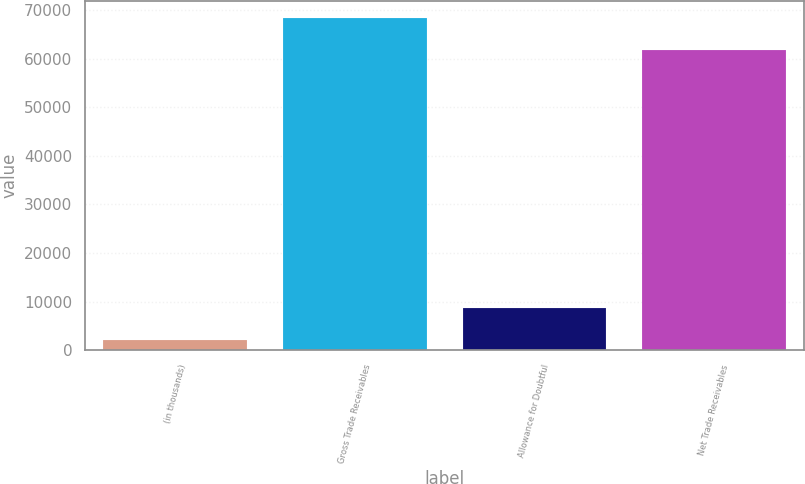<chart> <loc_0><loc_0><loc_500><loc_500><bar_chart><fcel>(in thousands)<fcel>Gross Trade Receivables<fcel>Allowance for Doubtful<fcel>Net Trade Receivables<nl><fcel>2011<fcel>68425<fcel>8652.4<fcel>61687<nl></chart> 